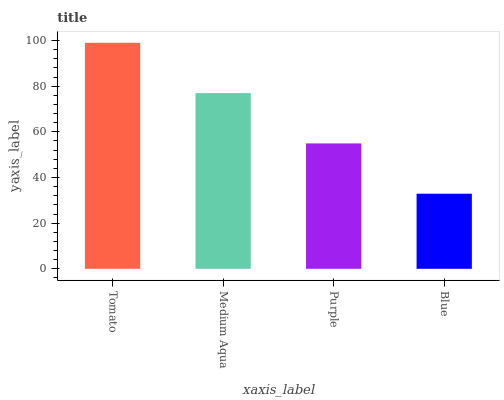Is Blue the minimum?
Answer yes or no. Yes. Is Tomato the maximum?
Answer yes or no. Yes. Is Medium Aqua the minimum?
Answer yes or no. No. Is Medium Aqua the maximum?
Answer yes or no. No. Is Tomato greater than Medium Aqua?
Answer yes or no. Yes. Is Medium Aqua less than Tomato?
Answer yes or no. Yes. Is Medium Aqua greater than Tomato?
Answer yes or no. No. Is Tomato less than Medium Aqua?
Answer yes or no. No. Is Medium Aqua the high median?
Answer yes or no. Yes. Is Purple the low median?
Answer yes or no. Yes. Is Blue the high median?
Answer yes or no. No. Is Medium Aqua the low median?
Answer yes or no. No. 